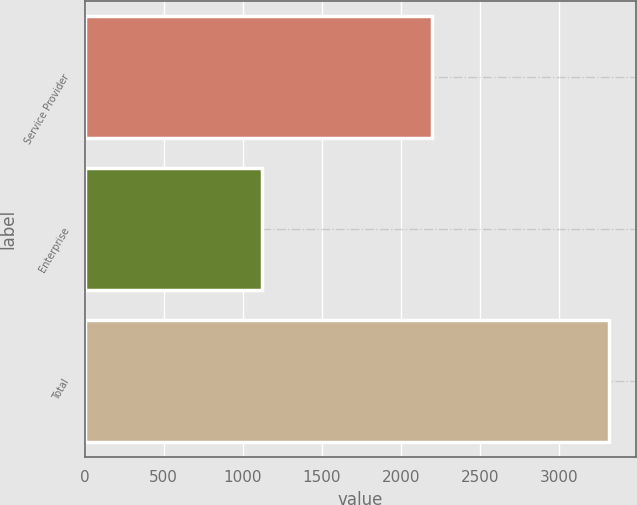<chart> <loc_0><loc_0><loc_500><loc_500><bar_chart><fcel>Service Provider<fcel>Enterprise<fcel>Total<nl><fcel>2197.1<fcel>1118.8<fcel>3315.9<nl></chart> 